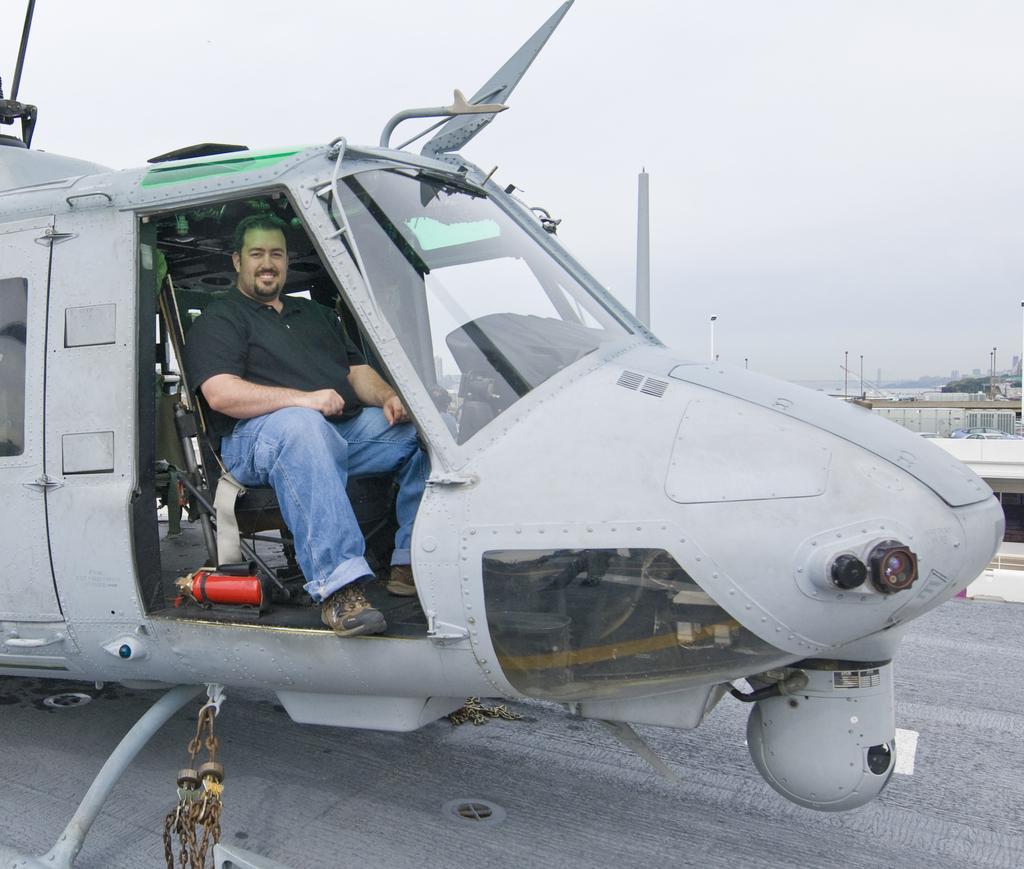Please provide a concise description of this image. In this picture we can see an airplane on the ground with a man sitting inside it and smiling and in the background we can see poles, sky. 